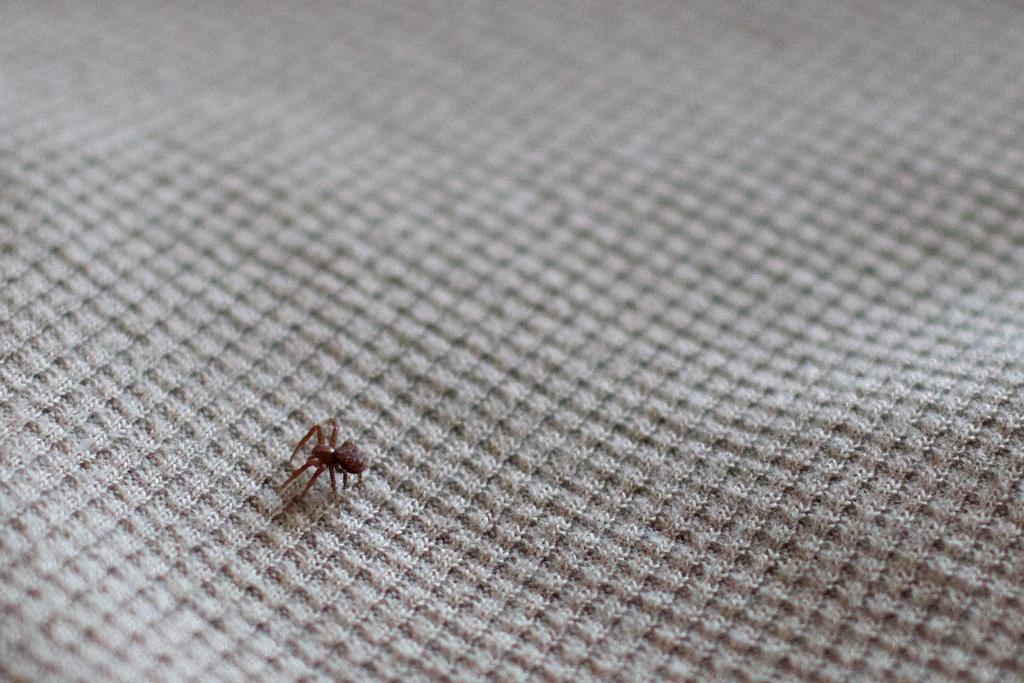Can you describe this image briefly? In this picture we can see an insect on a cloth. 